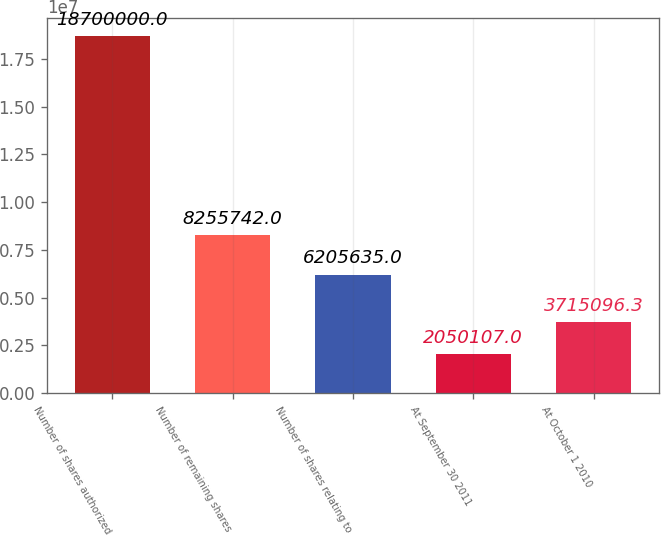Convert chart. <chart><loc_0><loc_0><loc_500><loc_500><bar_chart><fcel>Number of shares authorized<fcel>Number of remaining shares<fcel>Number of shares relating to<fcel>At September 30 2011<fcel>At October 1 2010<nl><fcel>1.87e+07<fcel>8.25574e+06<fcel>6.20564e+06<fcel>2.05011e+06<fcel>3.7151e+06<nl></chart> 